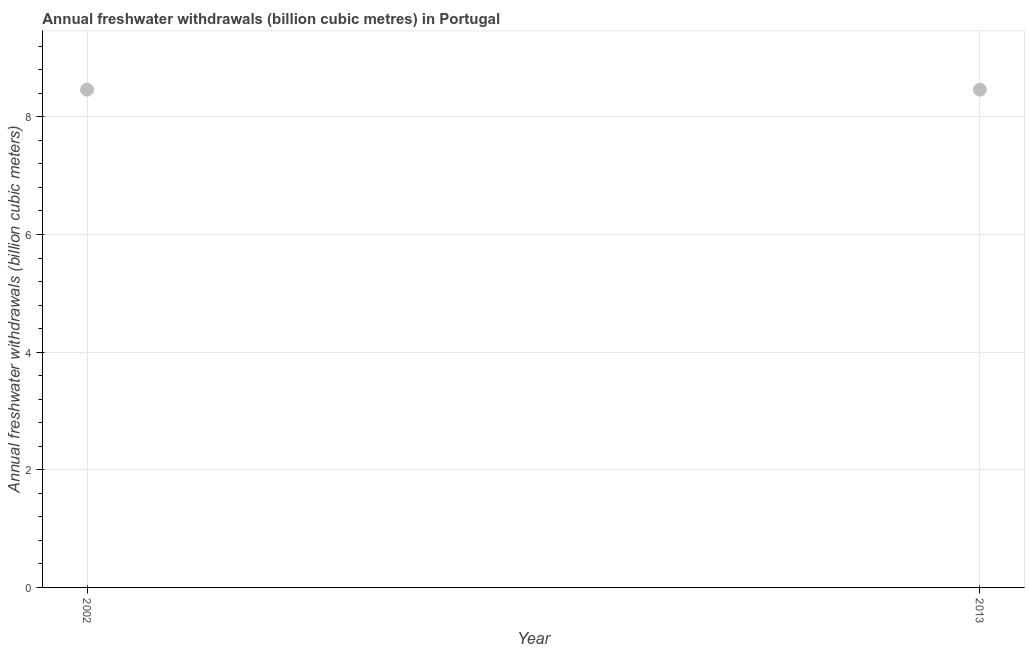What is the annual freshwater withdrawals in 2002?
Give a very brief answer. 8.46. Across all years, what is the maximum annual freshwater withdrawals?
Your answer should be very brief. 8.46. Across all years, what is the minimum annual freshwater withdrawals?
Offer a very short reply. 8.46. In which year was the annual freshwater withdrawals minimum?
Keep it short and to the point. 2002. What is the sum of the annual freshwater withdrawals?
Keep it short and to the point. 16.93. What is the average annual freshwater withdrawals per year?
Your answer should be compact. 8.46. What is the median annual freshwater withdrawals?
Make the answer very short. 8.46. Do a majority of the years between 2013 and 2002 (inclusive) have annual freshwater withdrawals greater than 1.2000000000000002 billion cubic meters?
Your response must be concise. No. What is the ratio of the annual freshwater withdrawals in 2002 to that in 2013?
Give a very brief answer. 1. Does the annual freshwater withdrawals monotonically increase over the years?
Your answer should be very brief. No. Are the values on the major ticks of Y-axis written in scientific E-notation?
Give a very brief answer. No. Does the graph contain grids?
Provide a succinct answer. Yes. What is the title of the graph?
Your answer should be very brief. Annual freshwater withdrawals (billion cubic metres) in Portugal. What is the label or title of the X-axis?
Your answer should be very brief. Year. What is the label or title of the Y-axis?
Provide a succinct answer. Annual freshwater withdrawals (billion cubic meters). What is the Annual freshwater withdrawals (billion cubic meters) in 2002?
Keep it short and to the point. 8.46. What is the Annual freshwater withdrawals (billion cubic meters) in 2013?
Give a very brief answer. 8.46. 